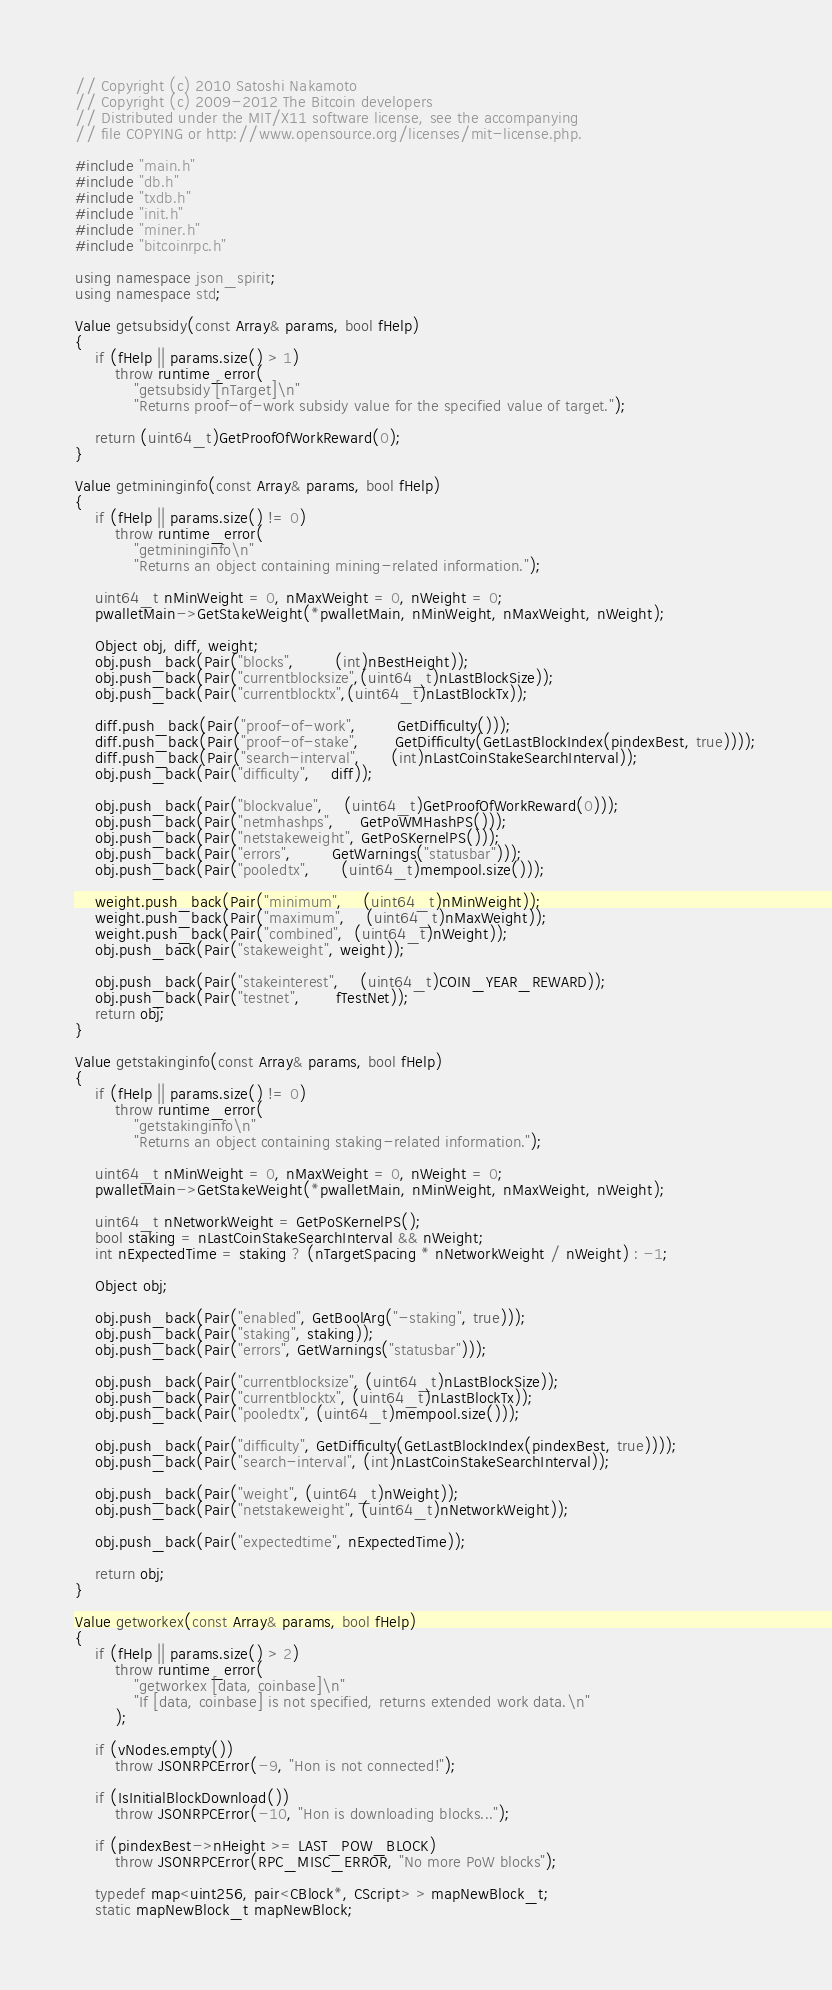<code> <loc_0><loc_0><loc_500><loc_500><_C++_>// Copyright (c) 2010 Satoshi Nakamoto
// Copyright (c) 2009-2012 The Bitcoin developers
// Distributed under the MIT/X11 software license, see the accompanying
// file COPYING or http://www.opensource.org/licenses/mit-license.php.

#include "main.h"
#include "db.h"
#include "txdb.h"
#include "init.h"
#include "miner.h"
#include "bitcoinrpc.h"

using namespace json_spirit;
using namespace std;

Value getsubsidy(const Array& params, bool fHelp)
{
    if (fHelp || params.size() > 1)
        throw runtime_error(
            "getsubsidy [nTarget]\n"
            "Returns proof-of-work subsidy value for the specified value of target.");

    return (uint64_t)GetProofOfWorkReward(0);
}

Value getmininginfo(const Array& params, bool fHelp)
{
    if (fHelp || params.size() != 0)
        throw runtime_error(
            "getmininginfo\n"
            "Returns an object containing mining-related information.");

    uint64_t nMinWeight = 0, nMaxWeight = 0, nWeight = 0;
    pwalletMain->GetStakeWeight(*pwalletMain, nMinWeight, nMaxWeight, nWeight);

    Object obj, diff, weight;
    obj.push_back(Pair("blocks",        (int)nBestHeight));
    obj.push_back(Pair("currentblocksize",(uint64_t)nLastBlockSize));
    obj.push_back(Pair("currentblocktx",(uint64_t)nLastBlockTx));

    diff.push_back(Pair("proof-of-work",        GetDifficulty()));
    diff.push_back(Pair("proof-of-stake",       GetDifficulty(GetLastBlockIndex(pindexBest, true))));
    diff.push_back(Pair("search-interval",      (int)nLastCoinStakeSearchInterval));
    obj.push_back(Pair("difficulty",    diff));

    obj.push_back(Pair("blockvalue",    (uint64_t)GetProofOfWorkReward(0)));
    obj.push_back(Pair("netmhashps",     GetPoWMHashPS()));
    obj.push_back(Pair("netstakeweight", GetPoSKernelPS()));
    obj.push_back(Pair("errors",        GetWarnings("statusbar")));
    obj.push_back(Pair("pooledtx",      (uint64_t)mempool.size()));

    weight.push_back(Pair("minimum",    (uint64_t)nMinWeight));
    weight.push_back(Pair("maximum",    (uint64_t)nMaxWeight));
    weight.push_back(Pair("combined",  (uint64_t)nWeight));
    obj.push_back(Pair("stakeweight", weight));

    obj.push_back(Pair("stakeinterest",    (uint64_t)COIN_YEAR_REWARD));
    obj.push_back(Pair("testnet",       fTestNet));
    return obj;
}

Value getstakinginfo(const Array& params, bool fHelp)
{
    if (fHelp || params.size() != 0)
        throw runtime_error(
            "getstakinginfo\n"
            "Returns an object containing staking-related information.");

    uint64_t nMinWeight = 0, nMaxWeight = 0, nWeight = 0;
    pwalletMain->GetStakeWeight(*pwalletMain, nMinWeight, nMaxWeight, nWeight);

    uint64_t nNetworkWeight = GetPoSKernelPS();
    bool staking = nLastCoinStakeSearchInterval && nWeight;
    int nExpectedTime = staking ? (nTargetSpacing * nNetworkWeight / nWeight) : -1;

    Object obj;

    obj.push_back(Pair("enabled", GetBoolArg("-staking", true)));
    obj.push_back(Pair("staking", staking));
    obj.push_back(Pair("errors", GetWarnings("statusbar")));

    obj.push_back(Pair("currentblocksize", (uint64_t)nLastBlockSize));
    obj.push_back(Pair("currentblocktx", (uint64_t)nLastBlockTx));
    obj.push_back(Pair("pooledtx", (uint64_t)mempool.size()));

    obj.push_back(Pair("difficulty", GetDifficulty(GetLastBlockIndex(pindexBest, true))));
    obj.push_back(Pair("search-interval", (int)nLastCoinStakeSearchInterval));

    obj.push_back(Pair("weight", (uint64_t)nWeight));
    obj.push_back(Pair("netstakeweight", (uint64_t)nNetworkWeight));

    obj.push_back(Pair("expectedtime", nExpectedTime));

    return obj;
}

Value getworkex(const Array& params, bool fHelp)
{
    if (fHelp || params.size() > 2)
        throw runtime_error(
            "getworkex [data, coinbase]\n"
            "If [data, coinbase] is not specified, returns extended work data.\n"
        );

    if (vNodes.empty())
        throw JSONRPCError(-9, "Hon is not connected!");

    if (IsInitialBlockDownload())
        throw JSONRPCError(-10, "Hon is downloading blocks...");

    if (pindexBest->nHeight >= LAST_POW_BLOCK)
        throw JSONRPCError(RPC_MISC_ERROR, "No more PoW blocks");

    typedef map<uint256, pair<CBlock*, CScript> > mapNewBlock_t;
    static mapNewBlock_t mapNewBlock;</code> 